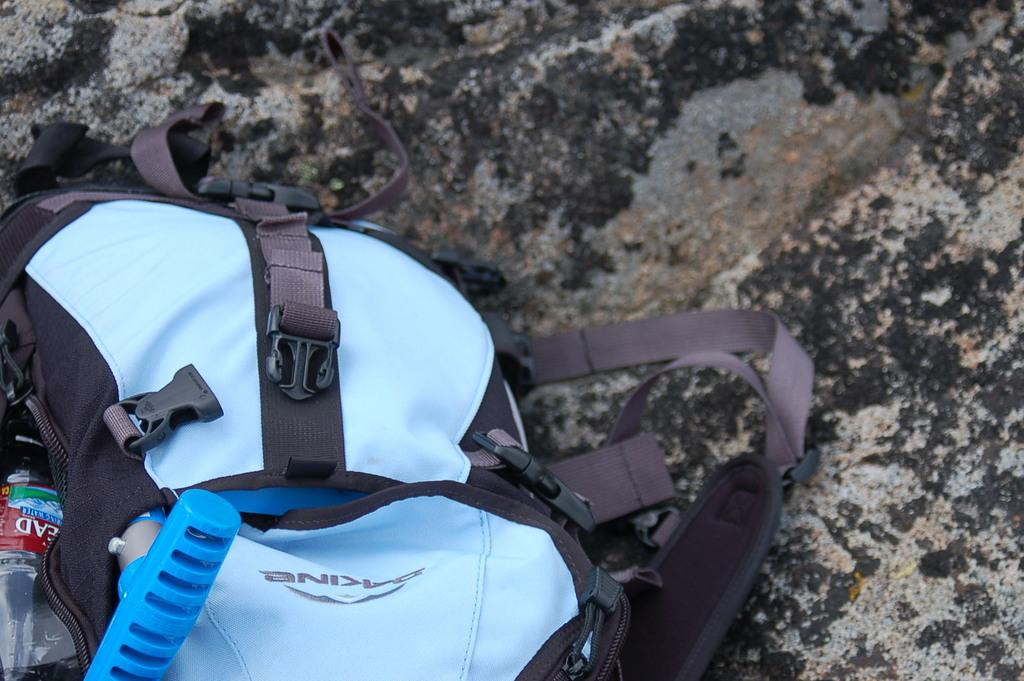What object is present in the image? There is a bag in the image. What colors are used for the bag? The bag is black and sky blue in color. What is inside the bag? The bag contains a water bottle. Where is the rabbit hiding in the image? There is no rabbit present in the image. What type of pickle is visible in the image? There is no pickle present in the image. 